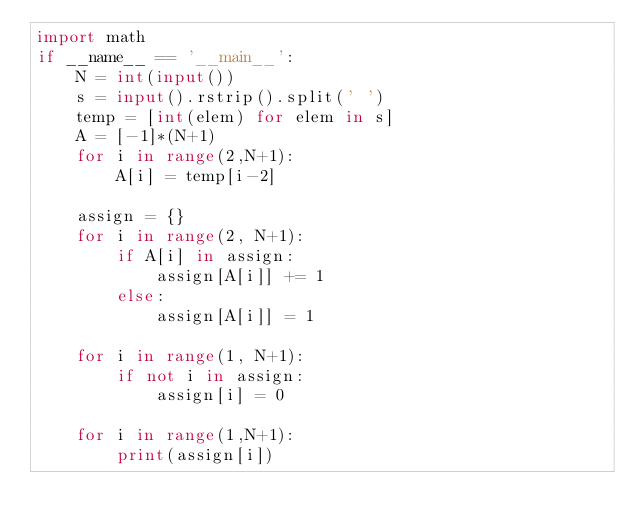Convert code to text. <code><loc_0><loc_0><loc_500><loc_500><_Python_>import math
if __name__ == '__main__':
    N = int(input())
    s = input().rstrip().split(' ')
    temp = [int(elem) for elem in s] 
    A = [-1]*(N+1)
    for i in range(2,N+1):
        A[i] = temp[i-2]

    assign = {}
    for i in range(2, N+1):
        if A[i] in assign:
            assign[A[i]] += 1
        else:
            assign[A[i]] = 1

    for i in range(1, N+1):
        if not i in assign:
            assign[i] = 0

    for i in range(1,N+1):
        print(assign[i])
</code> 